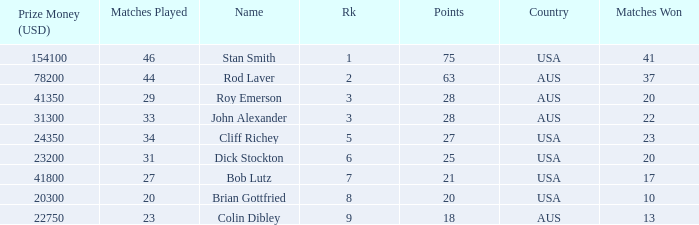How many countries had 21 points 1.0. 